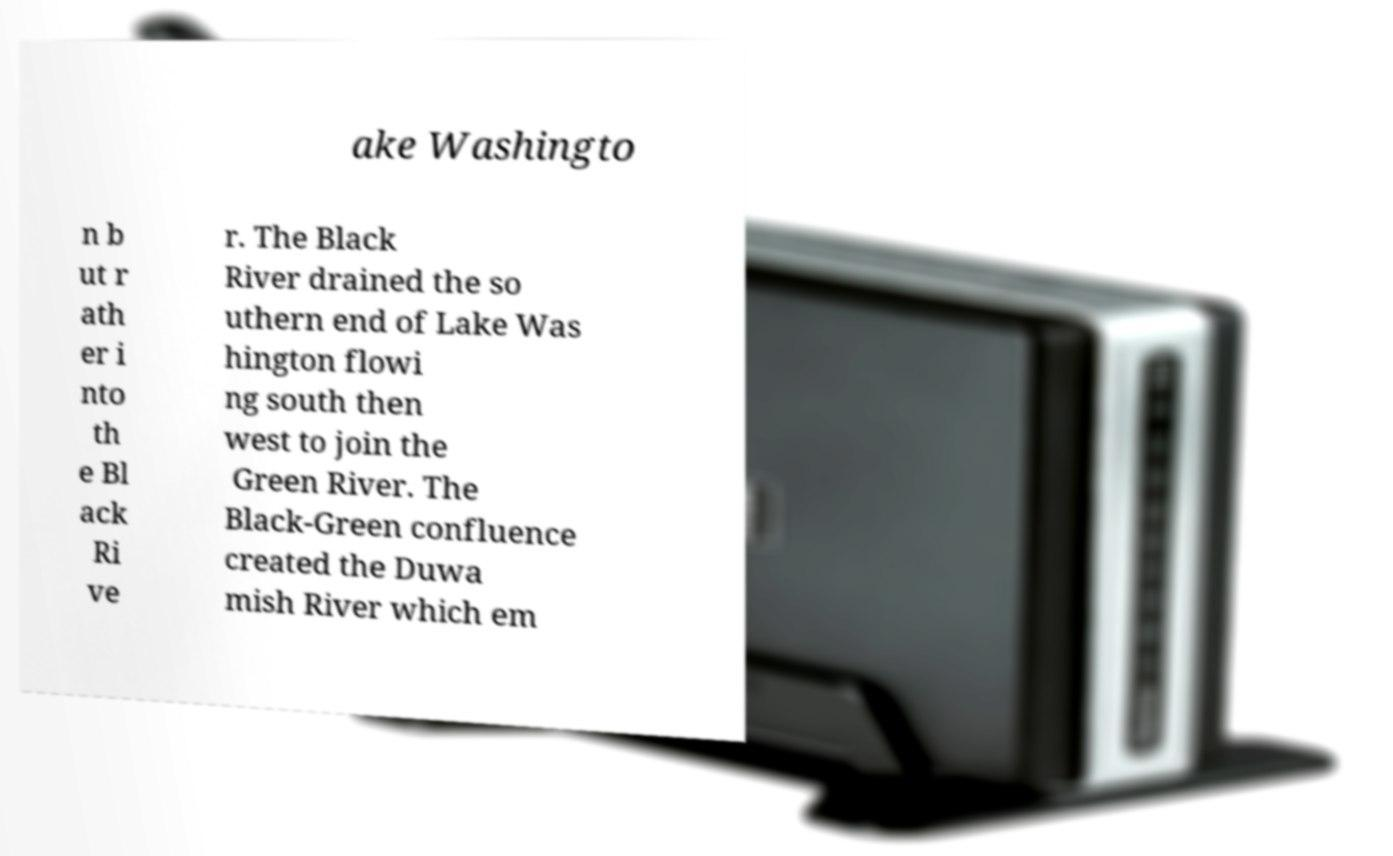Could you assist in decoding the text presented in this image and type it out clearly? ake Washingto n b ut r ath er i nto th e Bl ack Ri ve r. The Black River drained the so uthern end of Lake Was hington flowi ng south then west to join the Green River. The Black-Green confluence created the Duwa mish River which em 